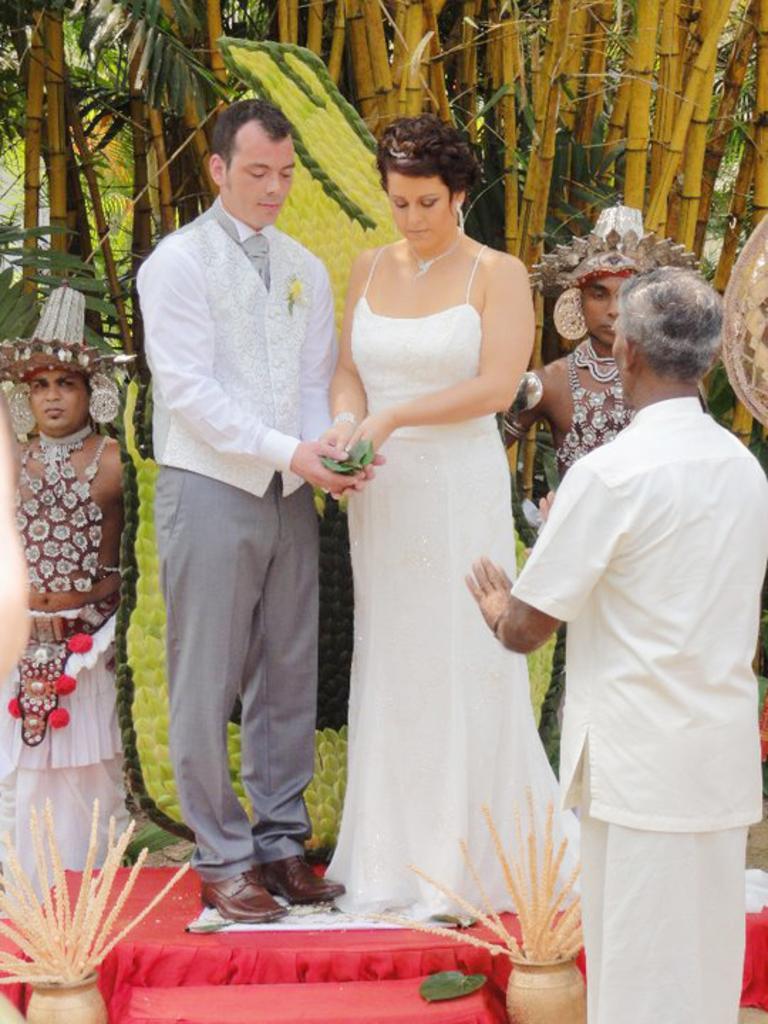Describe this image in one or two sentences. In this picture we can observe a couple standing. Both of them are wearing white color dresses. There are some people standing in this picture. We can observe cream color pots on either sides of this picture. In the background there are trees. We can observe a red color carpet. 